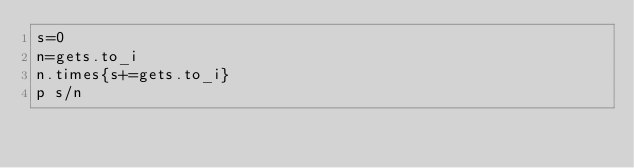Convert code to text. <code><loc_0><loc_0><loc_500><loc_500><_Ruby_>s=0
n=gets.to_i
n.times{s+=gets.to_i}
p s/n</code> 